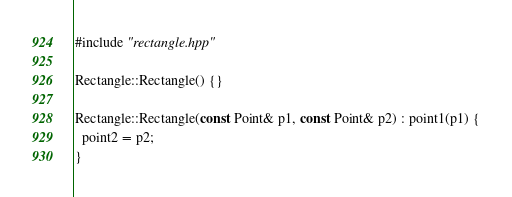<code> <loc_0><loc_0><loc_500><loc_500><_C++_>#include "rectangle.hpp"

Rectangle::Rectangle() {}

Rectangle::Rectangle(const Point& p1, const Point& p2) : point1(p1) {
  point2 = p2;
}
</code> 